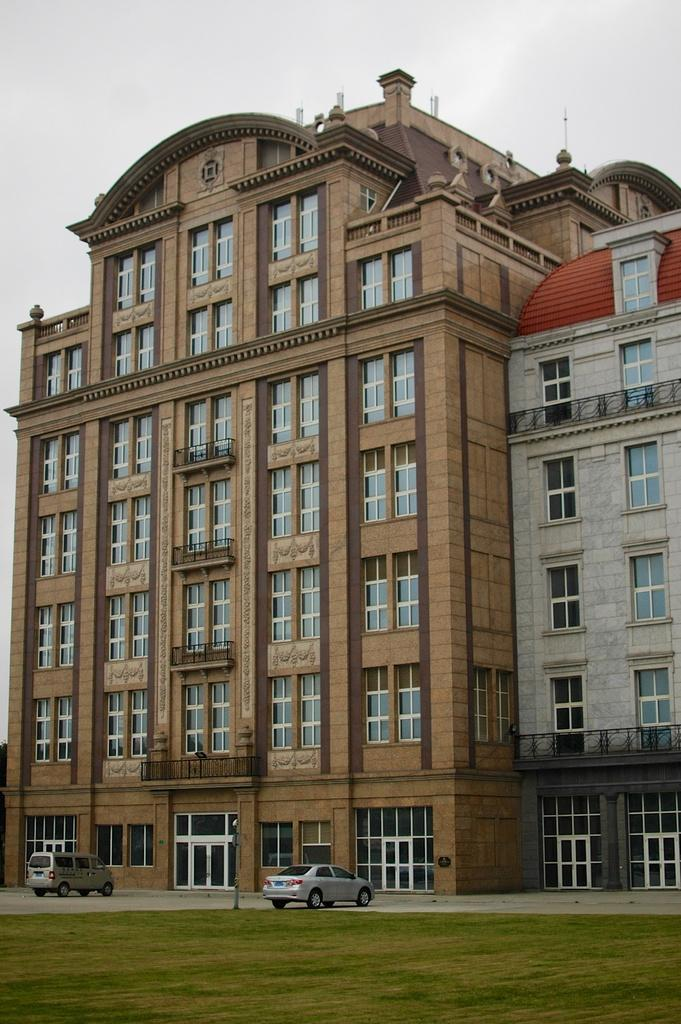What type of structure is present in the image? There is a building in the image. What feature of the building is mentioned in the facts? The building has many windows. What can be seen in front of the building? There are cars on the road in front of the building. What is visible above the building? The sky is visible above the building. Can you see any laborers working on the building in the image? There is no mention of laborers or any construction work in progress in the image. 